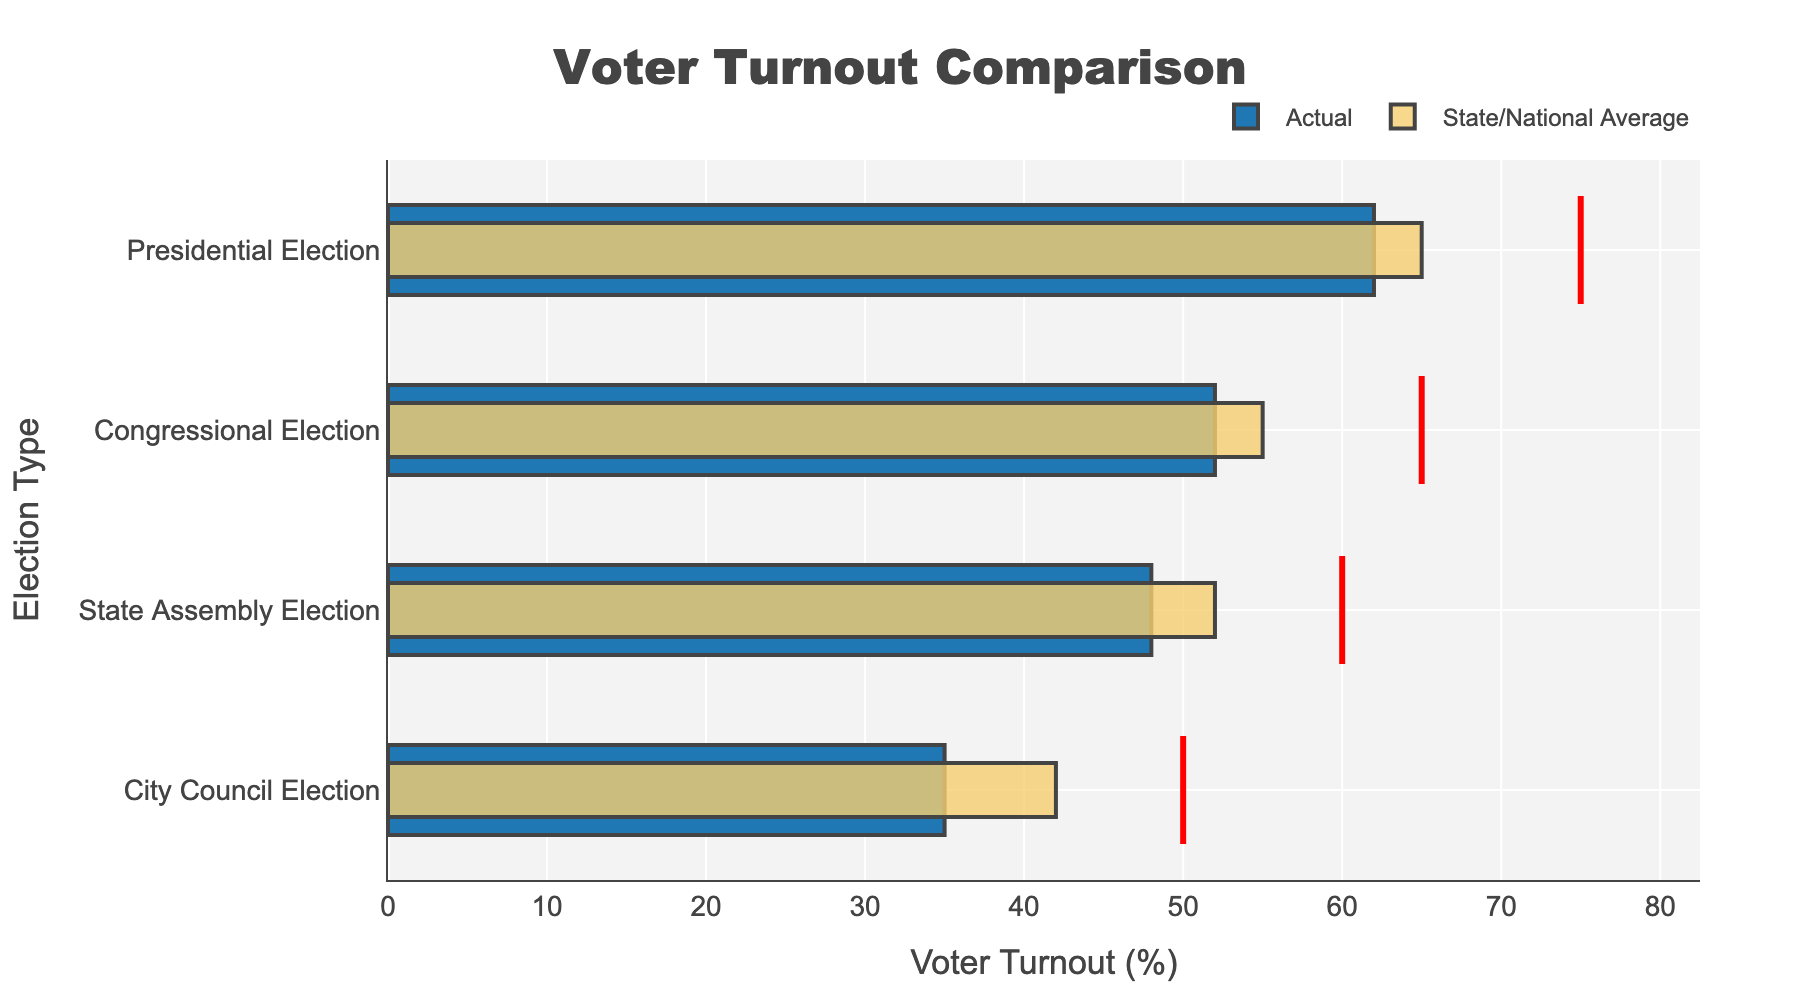What is the voter turnout percentage for the City Council Election? Locate the bar representing "Actual" for the City Council Election category. The voter turnout is clearly marked at 35%.
Answer: 35% How much higher is the voter turnout in the Presidential Election compared to the City Council Election? Identify the "Actual" voter turnout for the Presidential Election (62%) and the City Council Election (35%). Subtract the City Council turnout from the Presidential turnout: 62% - 35% = 27%.
Answer: 27% Which type of election has the smallest difference between actual voter turnout and the target? Compare the difference between the target and the actual voter turnout for each category. The State Assembly Election shows an actual turnout of 48% and a target of 60%, leaving a difference of 12%. The other differences are greater.
Answer: State Assembly Election In which election type is the actual voter turnout closest to the state/national average? Find the election where the "Actual" bar is closest to the "State/National Average". For the Congressional Election, the "Actual" is 52% and the "State/National Average" is 55%, making a difference of only 3%.
Answer: Congressional Election What is the target turnout percentage for the Congressional Election, and is the actual turnout above or below this target? Find the line marking the target for the Congressional Election. The target is 65%. Then, check the "Actual" bar, which is at 52%, showing it's below the target.
Answer: 65%, below How does the actual voter turnout in City Council Elections compare to the state/national average? Observe the bars for "Actual" and "State/National Average" within the City Council Election category. The "Actual" turnout is 35% while the state/national average is higher at 42%.
Answer: lower What is the average voter turnout in actual numbers across all four elections shown? Sum the actual turnout figures for all four election types: 35% + 48% + 52% + 62% = 197%. Divide by the number of elections, 197% / 4 = 49.25%.
Answer: 49.25% Which election shows the greatest discrepancy between actual turnout and the state/national average? Calculate the absolute difference between "Actual" and "State/National Average" for each election. The largest difference is for the City Council Election, where the actual turnout is 35% and the state/national average is 42%, making the discrepancy 7%.
Answer: City Council Election What is the sum of the target turnouts across all election types? Add the target percentage values for each election category: 50% + 60% + 65% + 75% = 250%.
Answer: 250% Is there any election type where the actual turnout exceeds the state/national average? Observe the "Actual" versus "State/National Average" bars across all election types. None of the "Actual" values exceed their respective "State/National Average" values.
Answer: No 